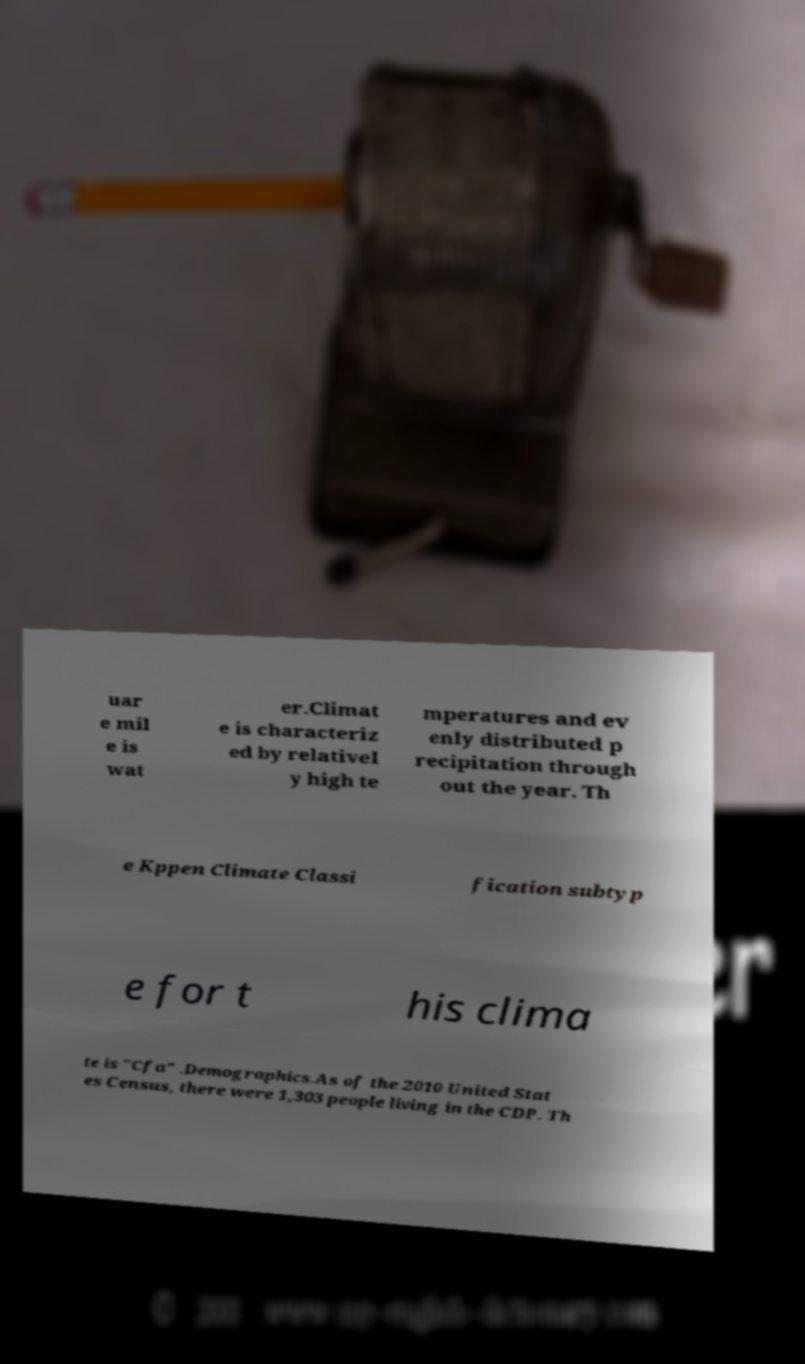For documentation purposes, I need the text within this image transcribed. Could you provide that? uar e mil e is wat er.Climat e is characteriz ed by relativel y high te mperatures and ev enly distributed p recipitation through out the year. Th e Kppen Climate Classi fication subtyp e for t his clima te is "Cfa" .Demographics.As of the 2010 United Stat es Census, there were 1,303 people living in the CDP. Th 